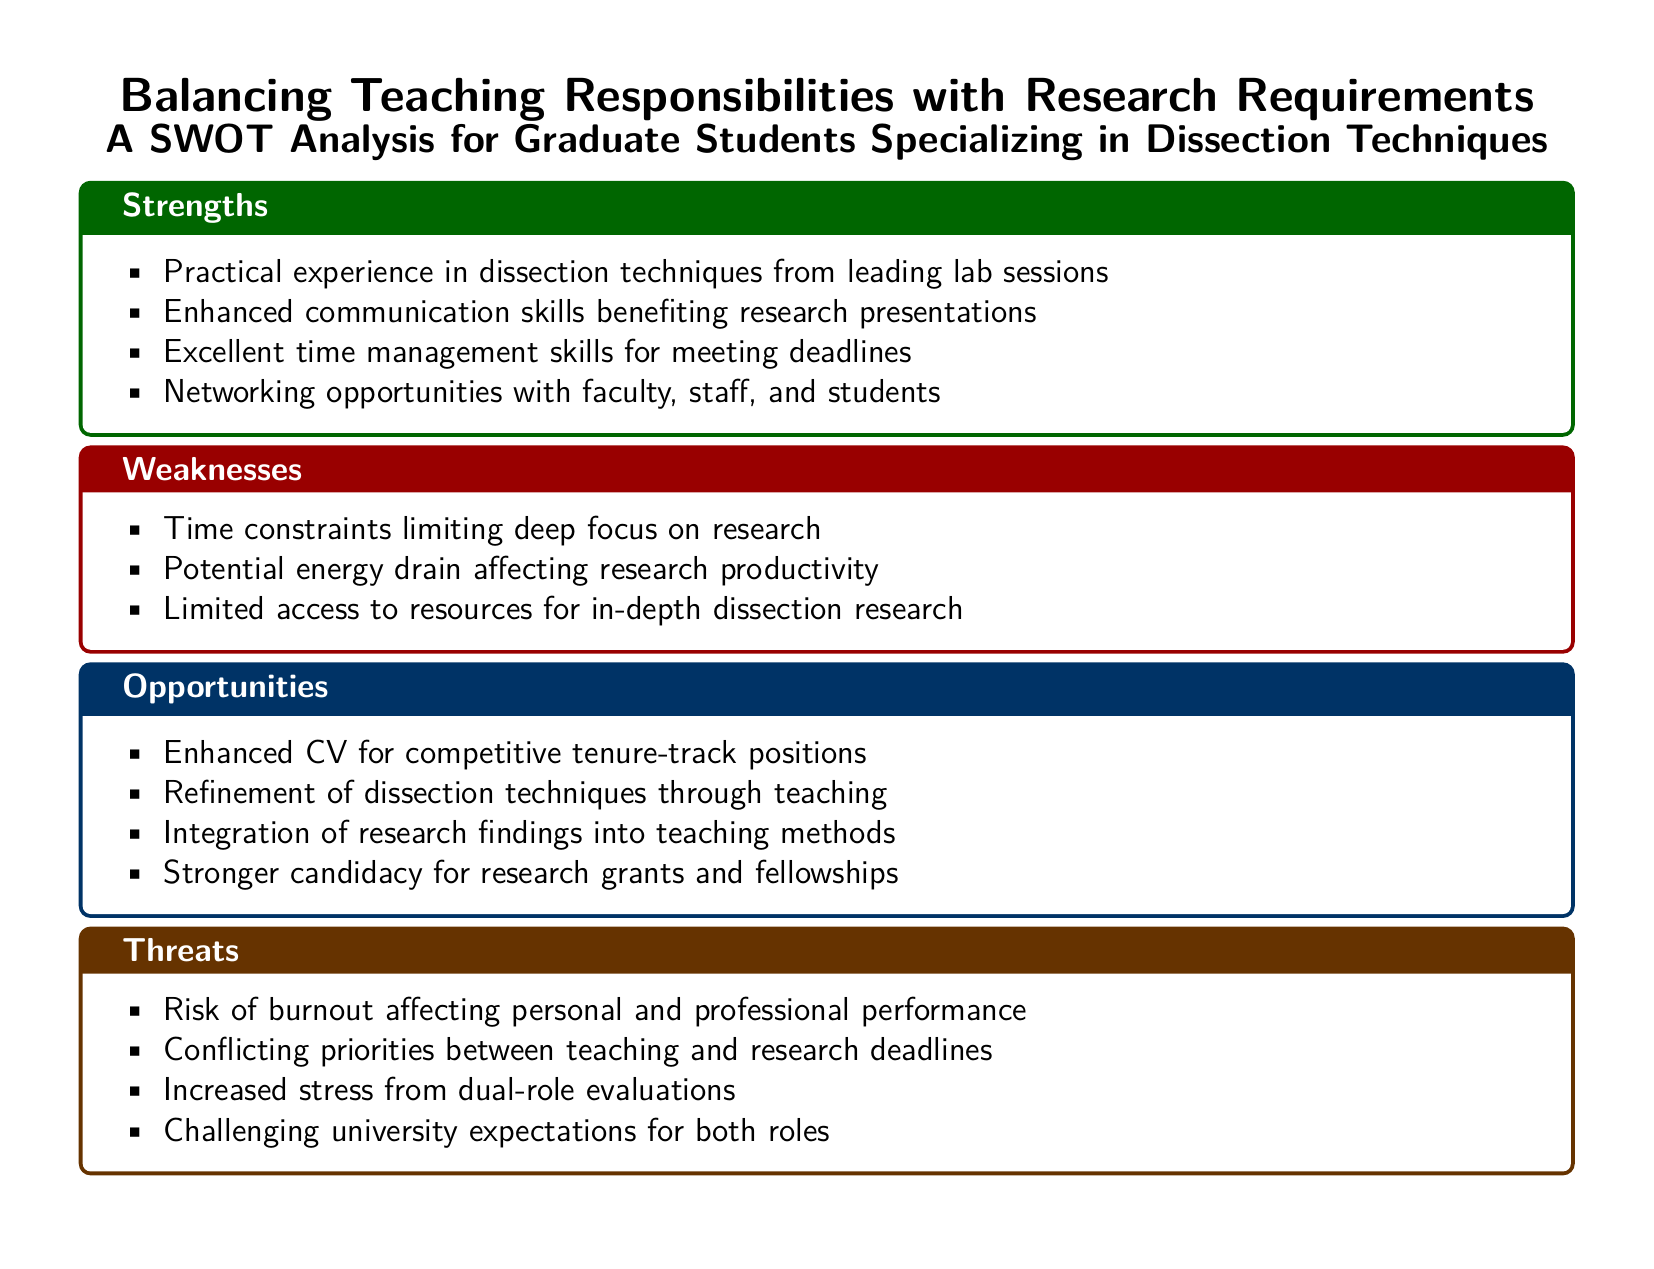What is one strength associated with teaching responsibilities? The document lists practical experience in dissection techniques from leading lab sessions as a strength.
Answer: Practical experience in dissection techniques What is a weakness that might affect research productivity? Time constraints limiting deep focus on research is noted as a weakness in the document.
Answer: Time constraints What opportunity is highlighted for improving one's CV? Enhanced CV for competitive tenure-track positions is mentioned in the opportunities section.
Answer: Enhanced CV for competitive tenure-track positions What is one threat related to managing dual roles? The document mentions the risk of burnout affecting personal and professional performance as a threat.
Answer: Risk of burnout How many strengths are listed in the document? The number of items in the strengths section indicates how many strengths are listed, which is four.
Answer: Four 